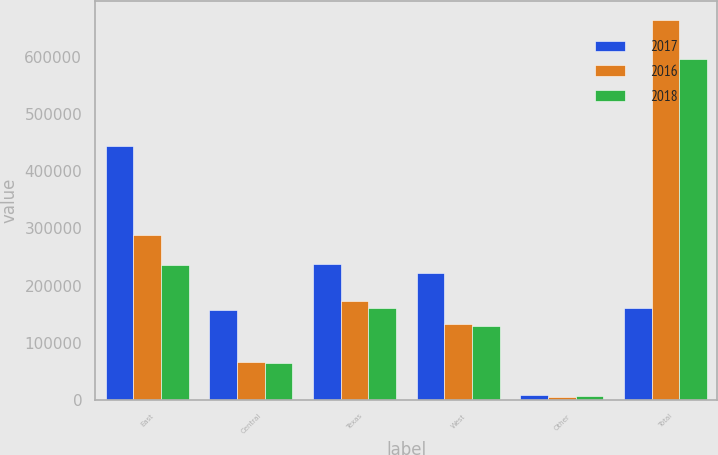Convert chart. <chart><loc_0><loc_0><loc_500><loc_500><stacked_bar_chart><ecel><fcel>East<fcel>Central<fcel>Texas<fcel>West<fcel>Other<fcel>Total<nl><fcel>2017<fcel>444122<fcel>157420<fcel>237703<fcel>222684<fcel>8195<fcel>160950<nl><fcel>2016<fcel>288138<fcel>66554<fcel>173005<fcel>132920<fcel>5122<fcel>665739<nl><fcel>2018<fcel>235377<fcel>64856<fcel>160950<fcel>128761<fcel>6355<fcel>596299<nl></chart> 